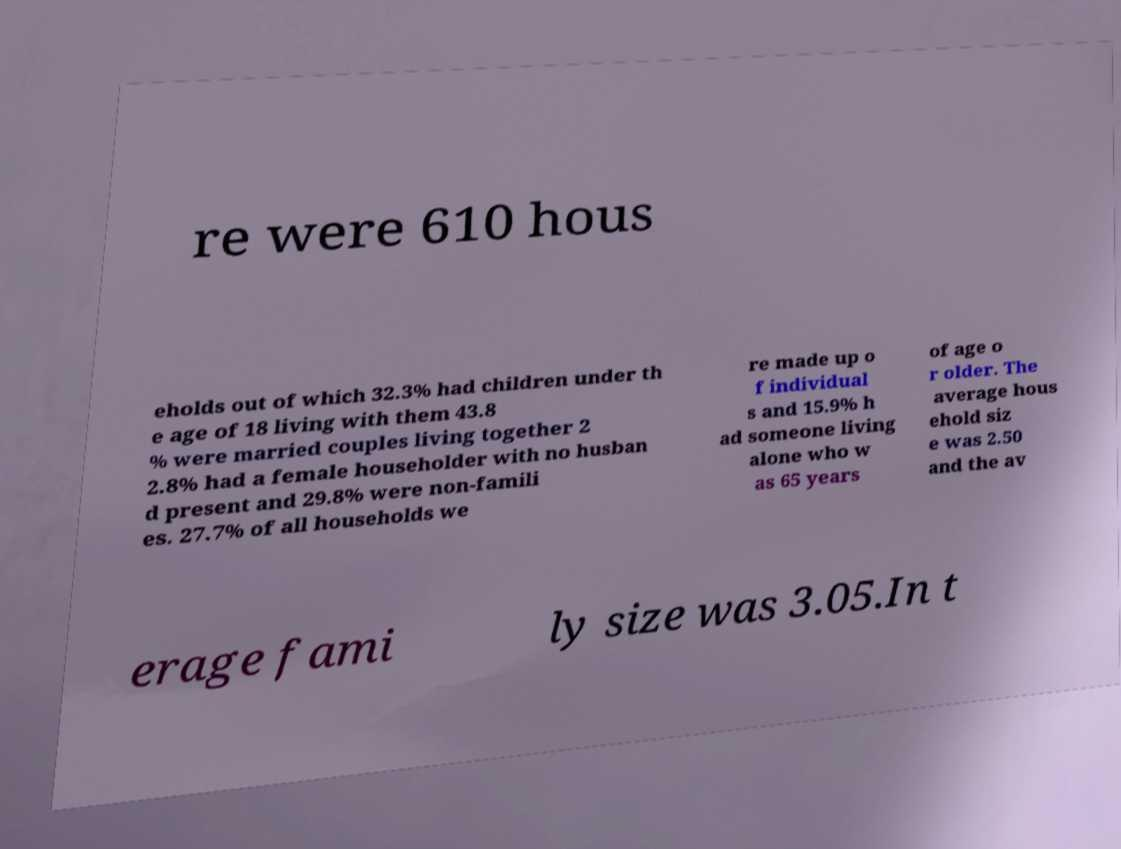Please read and relay the text visible in this image. What does it say? re were 610 hous eholds out of which 32.3% had children under th e age of 18 living with them 43.8 % were married couples living together 2 2.8% had a female householder with no husban d present and 29.8% were non-famili es. 27.7% of all households we re made up o f individual s and 15.9% h ad someone living alone who w as 65 years of age o r older. The average hous ehold siz e was 2.50 and the av erage fami ly size was 3.05.In t 